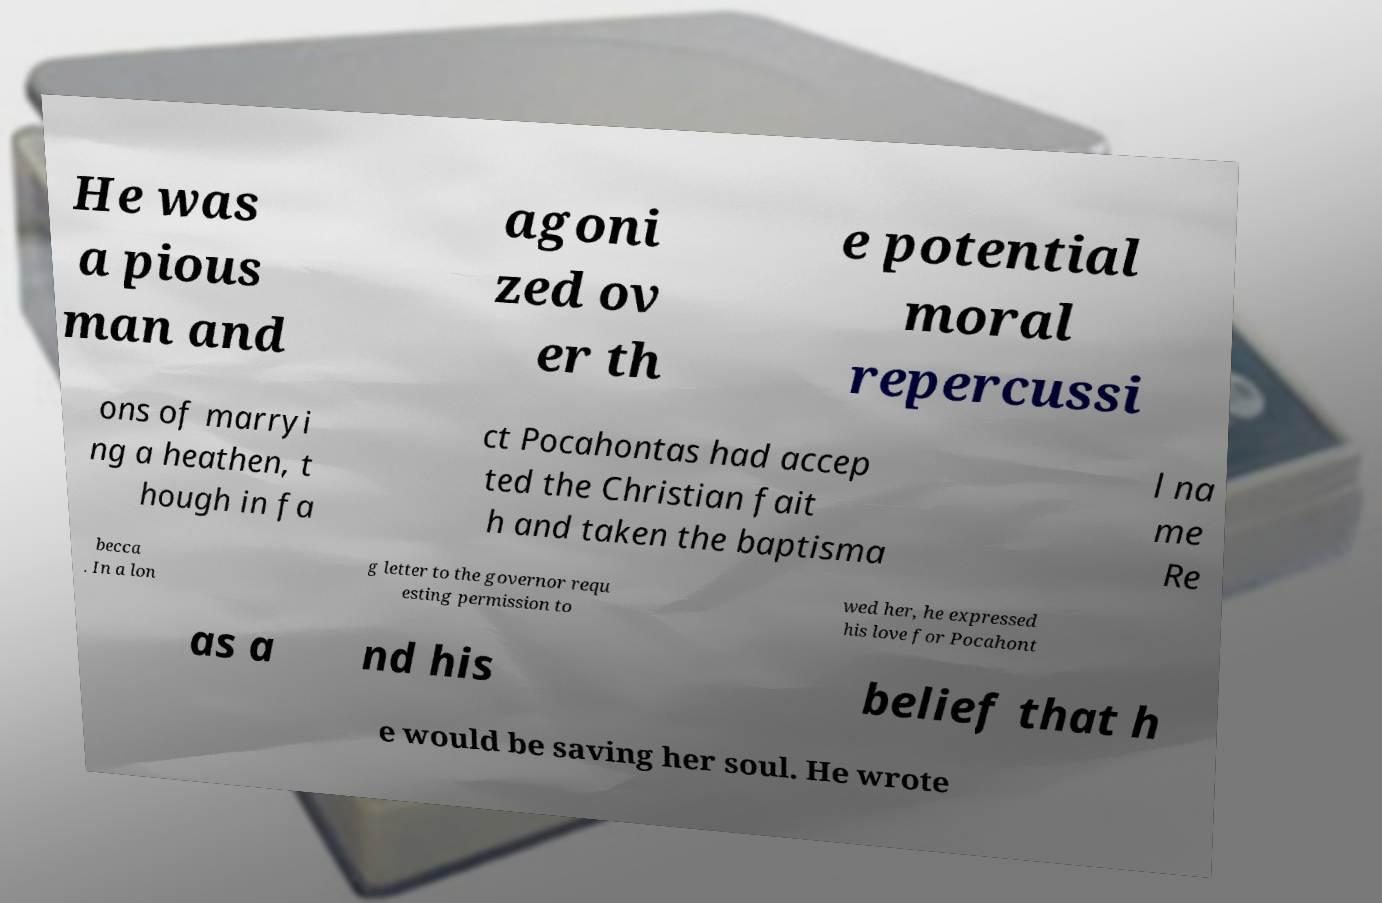What messages or text are displayed in this image? I need them in a readable, typed format. He was a pious man and agoni zed ov er th e potential moral repercussi ons of marryi ng a heathen, t hough in fa ct Pocahontas had accep ted the Christian fait h and taken the baptisma l na me Re becca . In a lon g letter to the governor requ esting permission to wed her, he expressed his love for Pocahont as a nd his belief that h e would be saving her soul. He wrote 